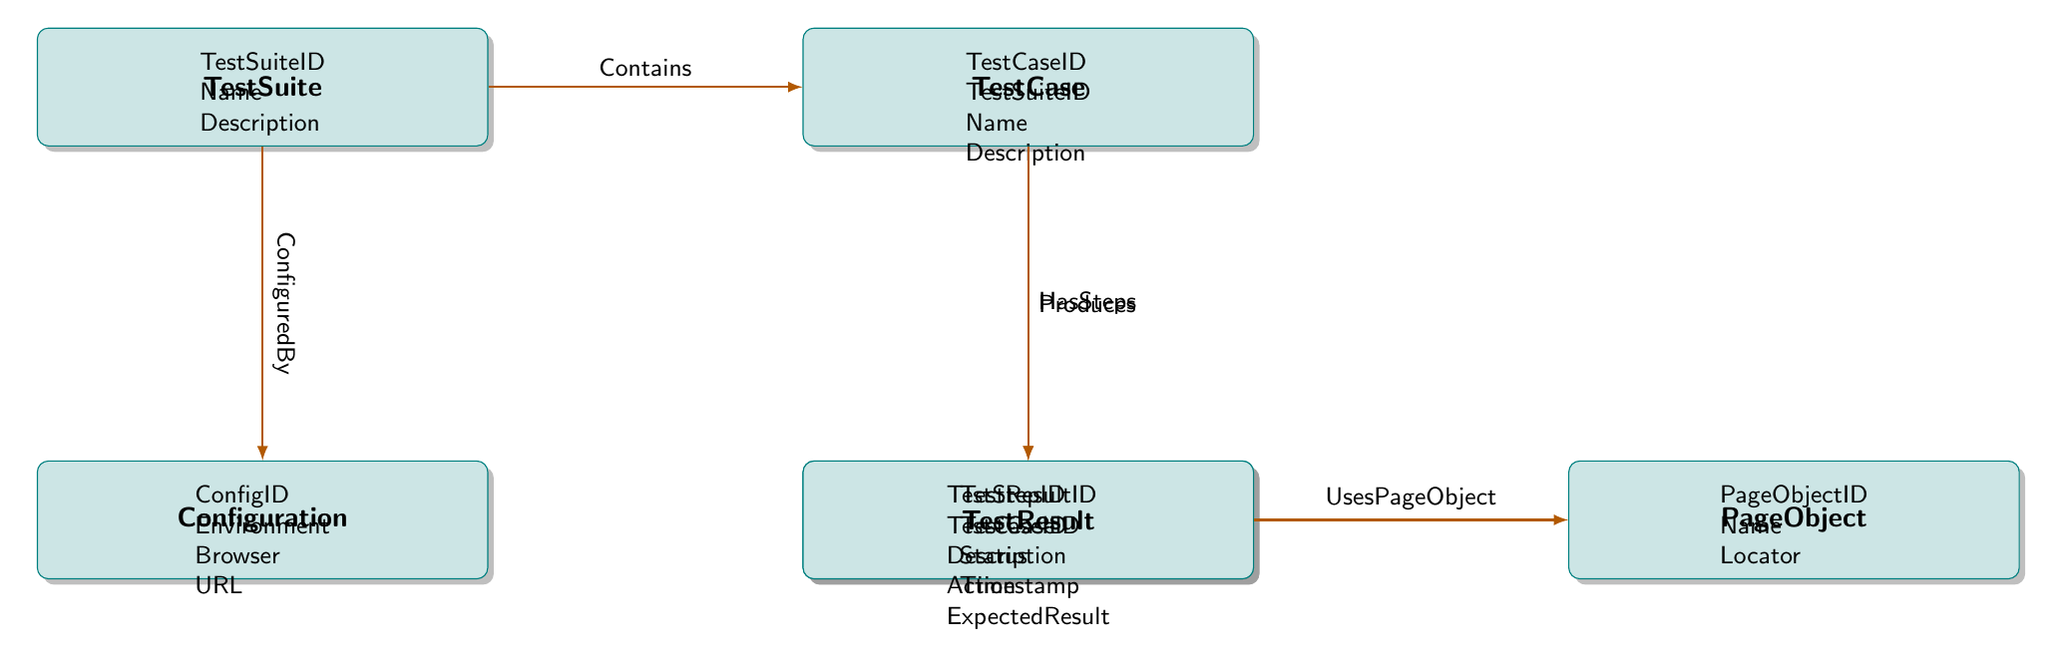What's the primary relationship between TestSuite and TestCase? The diagram shows that the primary relationship from TestSuite to TestCase is labeled as "Contains". This can be identified in the relationship lines connecting the two entities, indicating that one TestSuite can contain multiple TestCases.
Answer: Contains How many attributes are there in the Configuration entity? By examining the attributes listed under the Configuration entity, we can see there are four attributes: ConfigID, Environment, Browser, and URL. Thus, the total count of attributes is four.
Answer: 4 What does the relationship "UsesPageObject" signify in this diagram? The relationship labeled "UsesPageObject" between TestStep and PageObject indicates that each TestStep may utilize a single PageObject. This means that for each step in the test, there is an associated PageObject that aids in executing that step.
Answer: Each TestStep may utilize one PageObject Which entity is responsible for producing TestResults? The relationship labeled "Produces" points from TestCase to TestResult. This indicates that each TestCase is responsible for producing one or more TestResults upon execution.
Answer: TestCase How many entities are shown in the diagram? By counting the number of distinct entities depicted in the diagram, we identify six entities: TestSuite, TestCase, TestStep, Configuration, PageObject, and TestResult. Therefore, the total number of entities is six.
Answer: 6 What relationship connects TestSuite to Configuration? The relationship that connects TestSuite to Configuration is labeled "ConfiguredBy". This indicates a many-to-one relationship where multiple TestSuites may be configured by a single Configuration entity.
Answer: ConfiguredBy Which attribute is unique to the TestStep entity? The unique attribute to the TestStep entity, distinguishing it from other entities, is TestStepID, as it serves as the primary identifier for each step within a test case.
Answer: TestStepID How many TestSteps can a single TestCase have? The relationship labeled "HasSteps" indicates a one-to-many relationship from TestCase to TestStep, meaning that a single TestCase can have multiple TestSteps executed during its run. Therefore, the exact number can vary but can be multiple.
Answer: Multiple 